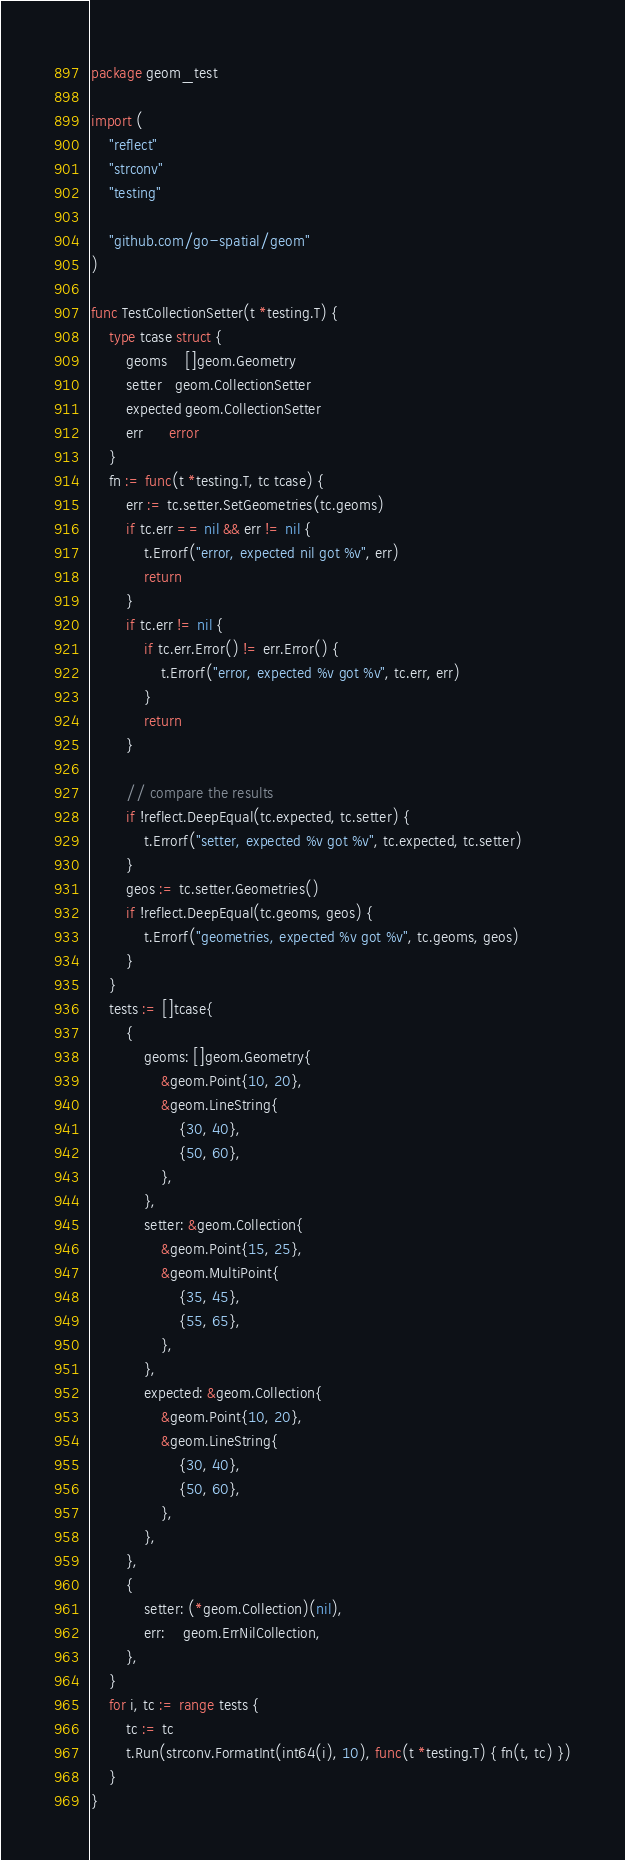Convert code to text. <code><loc_0><loc_0><loc_500><loc_500><_Go_>package geom_test

import (
	"reflect"
	"strconv"
	"testing"

	"github.com/go-spatial/geom"
)

func TestCollectionSetter(t *testing.T) {
	type tcase struct {
		geoms    []geom.Geometry
		setter   geom.CollectionSetter
		expected geom.CollectionSetter
		err      error
	}
	fn := func(t *testing.T, tc tcase) {
		err := tc.setter.SetGeometries(tc.geoms)
		if tc.err == nil && err != nil {
			t.Errorf("error, expected nil got %v", err)
			return
		}
		if tc.err != nil {
			if tc.err.Error() != err.Error() {
				t.Errorf("error, expected %v got %v", tc.err, err)
			}
			return
		}

		// compare the results
		if !reflect.DeepEqual(tc.expected, tc.setter) {
			t.Errorf("setter, expected %v got %v", tc.expected, tc.setter)
		}
		geos := tc.setter.Geometries()
		if !reflect.DeepEqual(tc.geoms, geos) {
			t.Errorf("geometries, expected %v got %v", tc.geoms, geos)
		}
	}
	tests := []tcase{
		{
			geoms: []geom.Geometry{
				&geom.Point{10, 20},
				&geom.LineString{
					{30, 40},
					{50, 60},
				},
			},
			setter: &geom.Collection{
				&geom.Point{15, 25},
				&geom.MultiPoint{
					{35, 45},
					{55, 65},
				},
			},
			expected: &geom.Collection{
				&geom.Point{10, 20},
				&geom.LineString{
					{30, 40},
					{50, 60},
				},
			},
		},
		{
			setter: (*geom.Collection)(nil),
			err:    geom.ErrNilCollection,
		},
	}
	for i, tc := range tests {
		tc := tc
		t.Run(strconv.FormatInt(int64(i), 10), func(t *testing.T) { fn(t, tc) })
	}
}
</code> 